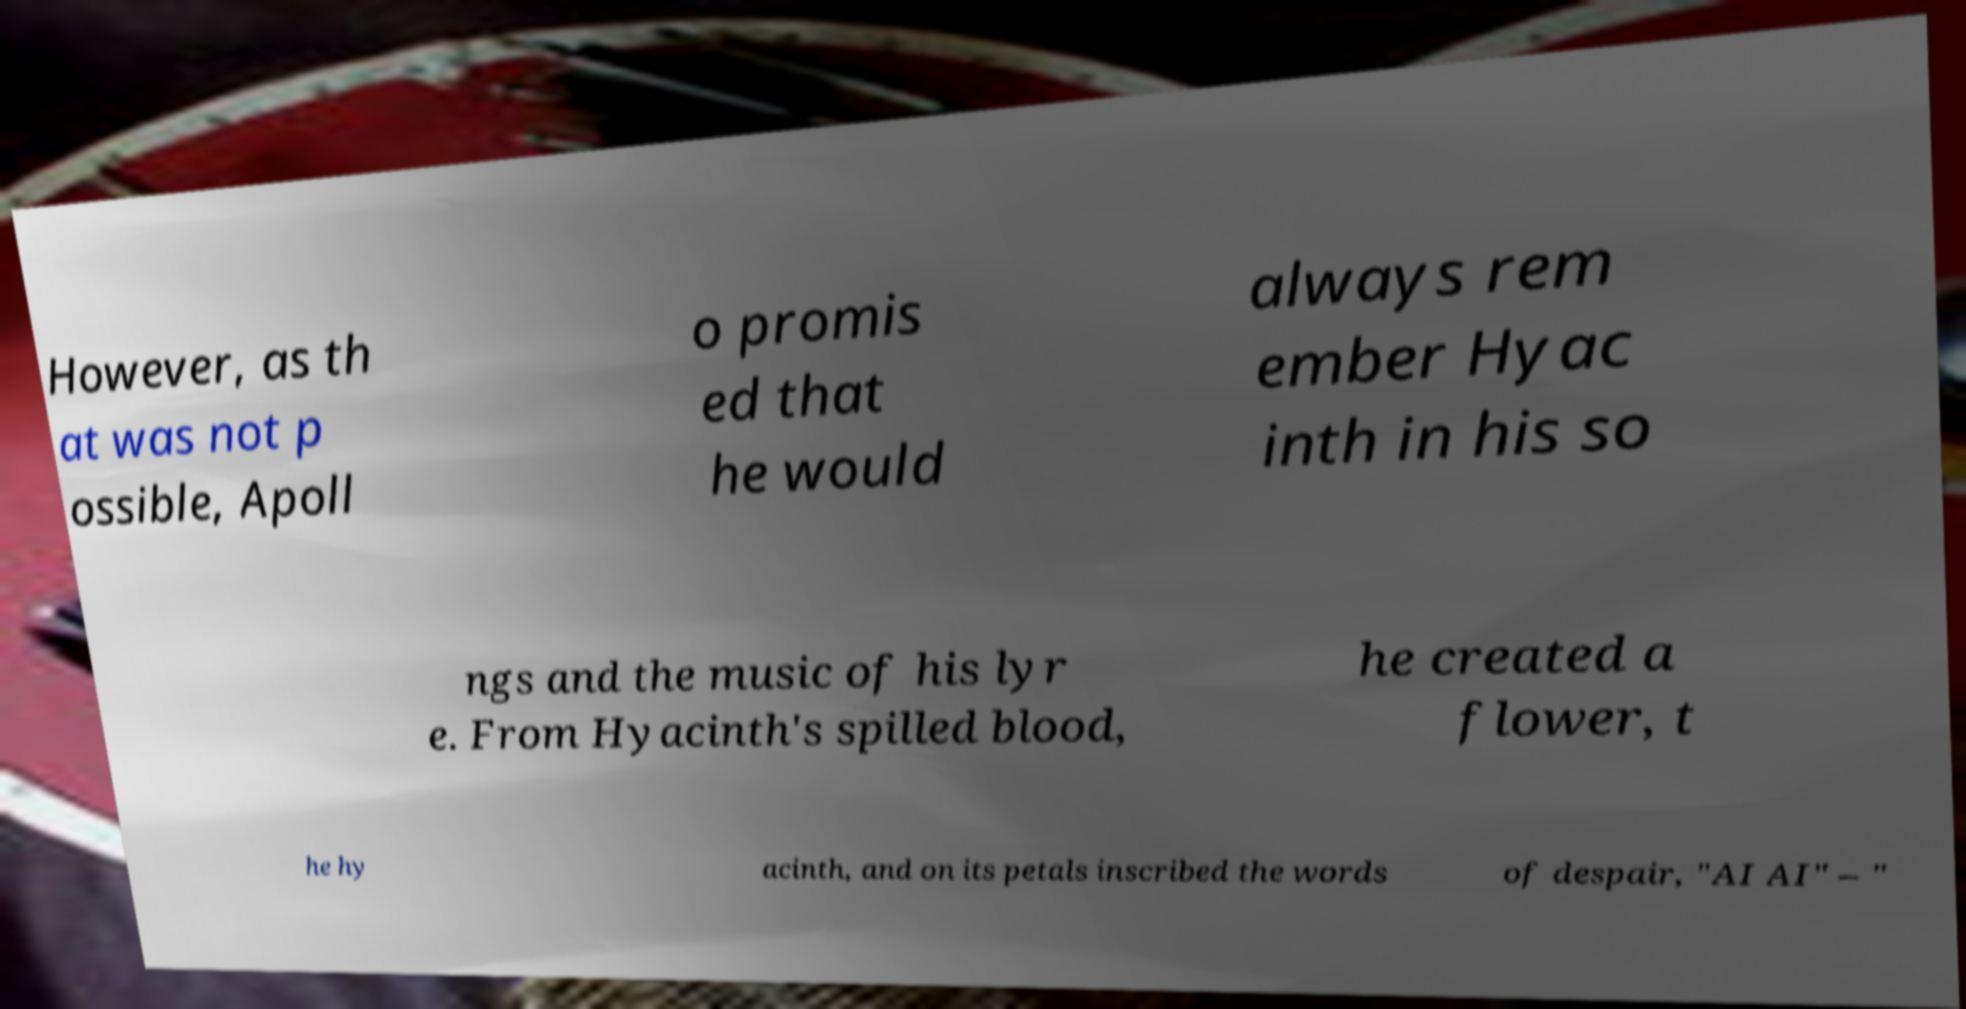For documentation purposes, I need the text within this image transcribed. Could you provide that? However, as th at was not p ossible, Apoll o promis ed that he would always rem ember Hyac inth in his so ngs and the music of his lyr e. From Hyacinth's spilled blood, he created a flower, t he hy acinth, and on its petals inscribed the words of despair, "AI AI" – " 